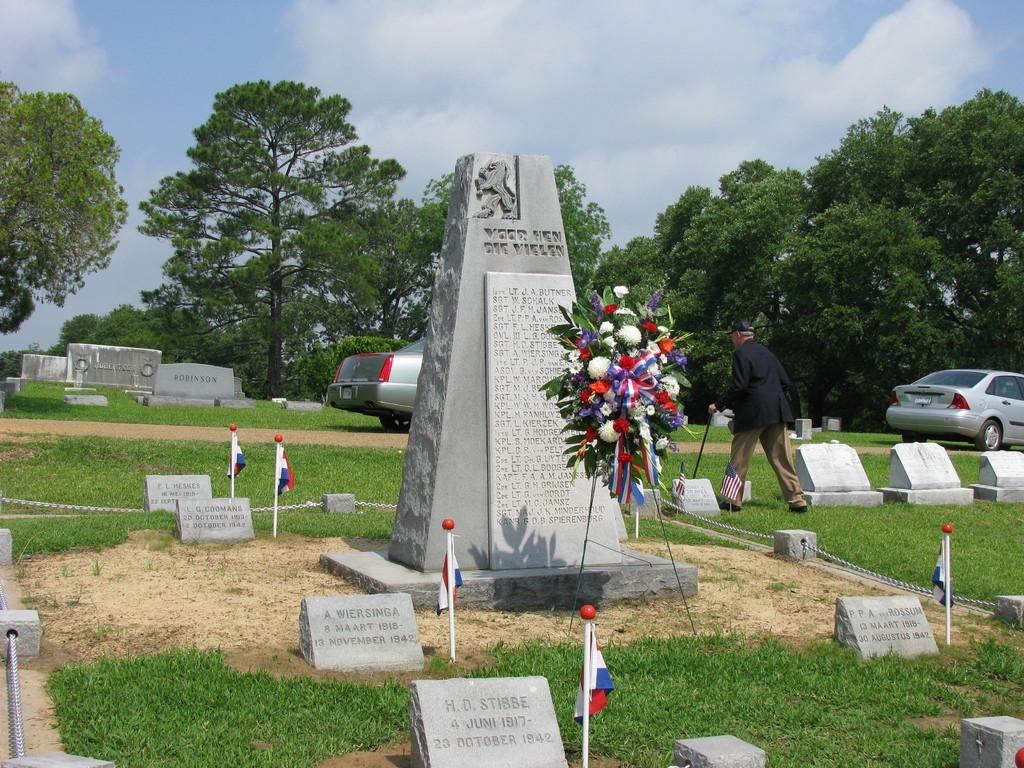What type of structures can be seen in the image? There are monuments in the image. What else is present in the image besides the monuments? There are flags, trees, vehicles, and a person walking in the image. What is the person holding in the image? The person is holding a stick. What is the color of the sky in the image? The sky is in white and blue color. Can you see any thread being used by the person in the image? There is no thread visible in the image; the person is holding a stick. Are there any ants crawling on the monuments in the image? There is no mention of ants in the image; the focus is on the monuments, flags, trees, vehicles, and the person walking. 